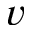<formula> <loc_0><loc_0><loc_500><loc_500>v</formula> 